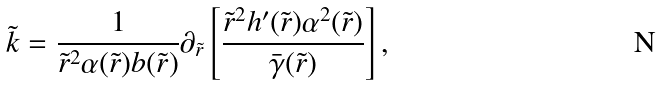Convert formula to latex. <formula><loc_0><loc_0><loc_500><loc_500>\tilde { k } = \frac { 1 } { \tilde { r } ^ { 2 } \alpha ( \tilde { r } ) b ( \tilde { r } ) } \partial _ { \tilde { r } } \left [ \frac { \tilde { r } ^ { 2 } h ^ { \prime } ( \tilde { r } ) \alpha ^ { 2 } ( \tilde { r } ) } { \bar { \gamma } ( \tilde { r } ) } \right ] ,</formula> 